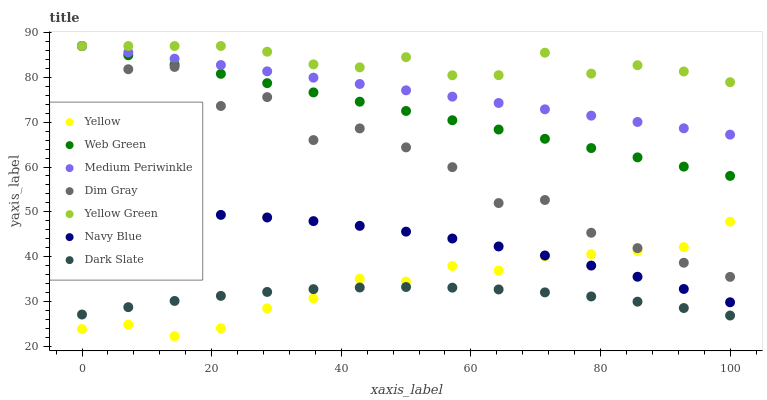Does Dark Slate have the minimum area under the curve?
Answer yes or no. Yes. Does Yellow Green have the maximum area under the curve?
Answer yes or no. Yes. Does Navy Blue have the minimum area under the curve?
Answer yes or no. No. Does Navy Blue have the maximum area under the curve?
Answer yes or no. No. Is Medium Periwinkle the smoothest?
Answer yes or no. Yes. Is Dim Gray the roughest?
Answer yes or no. Yes. Is Yellow Green the smoothest?
Answer yes or no. No. Is Yellow Green the roughest?
Answer yes or no. No. Does Yellow have the lowest value?
Answer yes or no. Yes. Does Navy Blue have the lowest value?
Answer yes or no. No. Does Web Green have the highest value?
Answer yes or no. Yes. Does Navy Blue have the highest value?
Answer yes or no. No. Is Navy Blue less than Yellow Green?
Answer yes or no. Yes. Is Web Green greater than Yellow?
Answer yes or no. Yes. Does Yellow intersect Dark Slate?
Answer yes or no. Yes. Is Yellow less than Dark Slate?
Answer yes or no. No. Is Yellow greater than Dark Slate?
Answer yes or no. No. Does Navy Blue intersect Yellow Green?
Answer yes or no. No. 